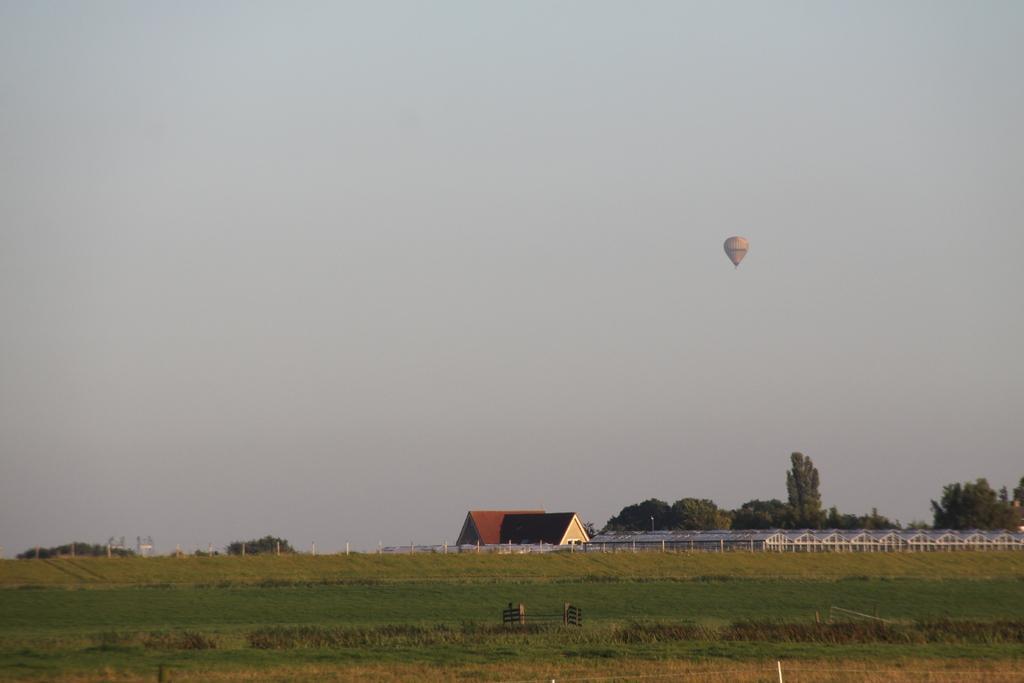In one or two sentences, can you explain what this image depicts? In this picture we can see houses, grass, trees and in the background we can see a parachute flying in the sky. 